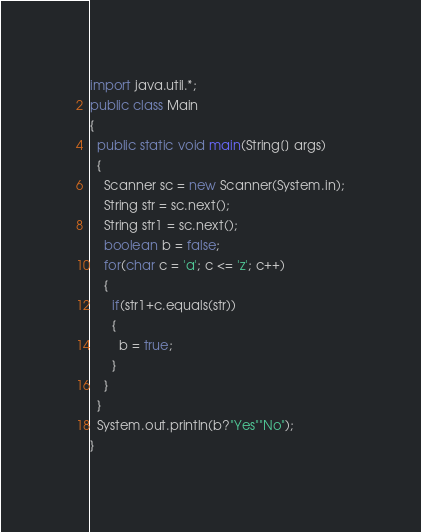<code> <loc_0><loc_0><loc_500><loc_500><_Java_>import java.util.*;
public class Main
{
  public static void main(String[] args)
  {
    Scanner sc = new Scanner(System.in);
    String str = sc.next();
    String str1 = sc.next();
    boolean b = false;
    for(char c = 'a'; c <= 'z'; c++)
    {
      if(str1+c.equals(str))
      {
        b = true;
      }
    }
  }
  System.out.println(b?"Yes""No");
}
</code> 